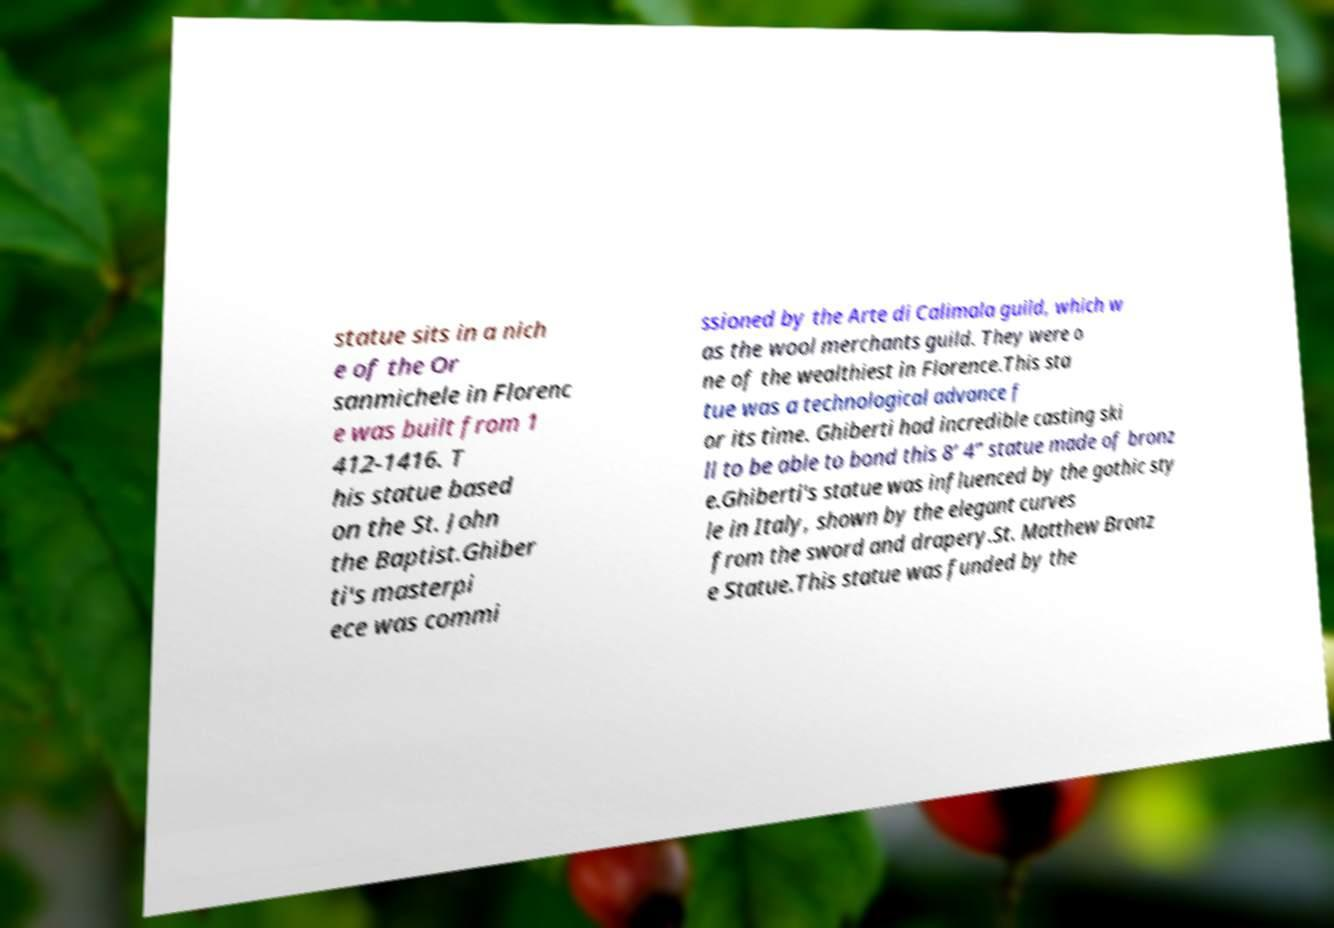For documentation purposes, I need the text within this image transcribed. Could you provide that? statue sits in a nich e of the Or sanmichele in Florenc e was built from 1 412-1416. T his statue based on the St. John the Baptist.Ghiber ti's masterpi ece was commi ssioned by the Arte di Calimala guild, which w as the wool merchants guild. They were o ne of the wealthiest in Florence.This sta tue was a technological advance f or its time. Ghiberti had incredible casting ski ll to be able to bond this 8’ 4” statue made of bronz e.Ghiberti's statue was influenced by the gothic sty le in Italy, shown by the elegant curves from the sword and drapery.St. Matthew Bronz e Statue.This statue was funded by the 